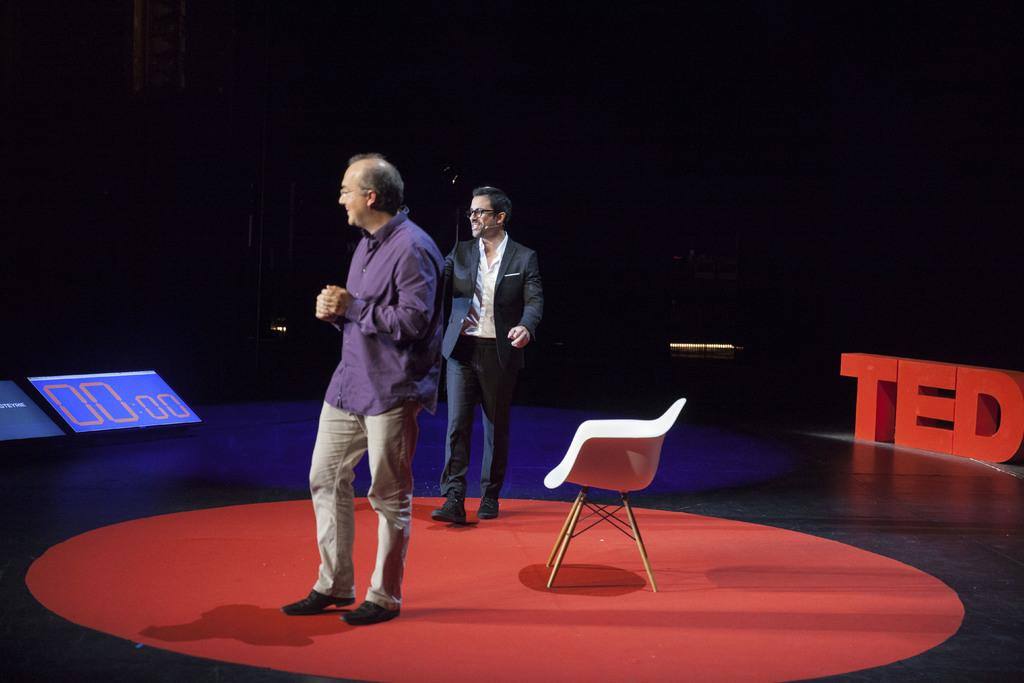What is the main subject of the image? There is a man standing in the image. What is the man doing with his hands? The man is holding his hands. Can you describe the person walking behind the man? The person walking behind the man is smiling. What object with a number display can be seen in the image? There is a timer with a number display in the image. What type of night can be seen in the image? There is no reference to a night or any specific time of day in the image. Can you tell me how many sisters the man has in the image? There is no mention of any family members or siblings in the image. 